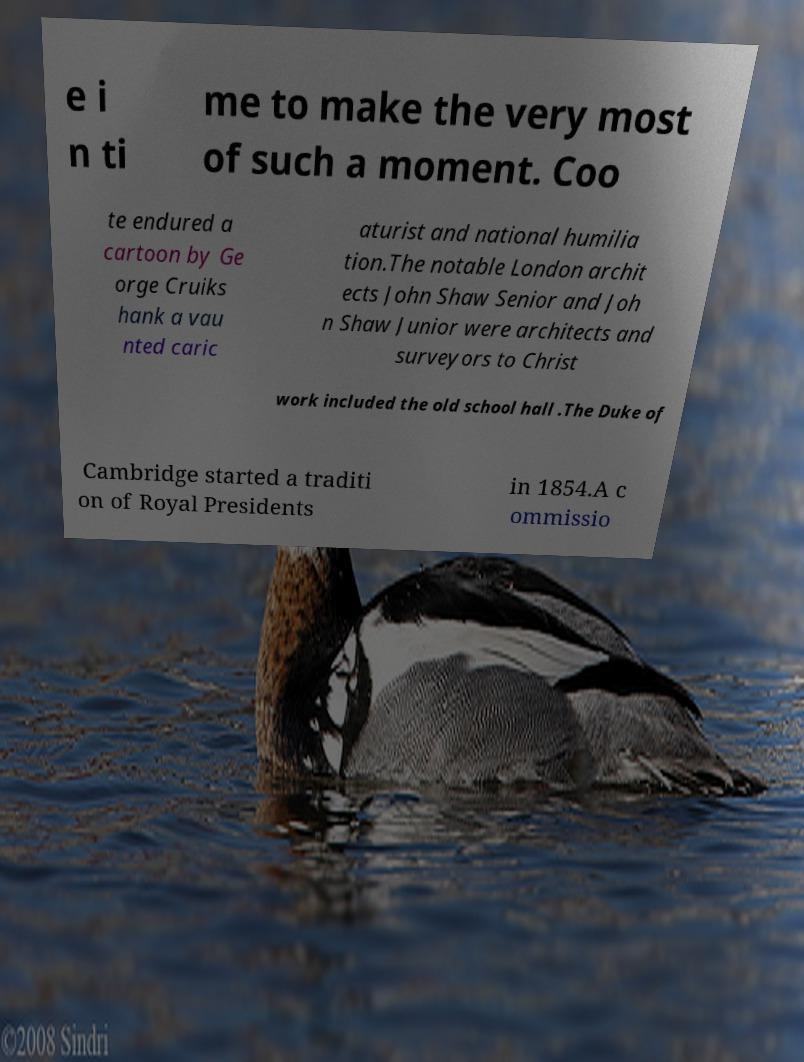There's text embedded in this image that I need extracted. Can you transcribe it verbatim? e i n ti me to make the very most of such a moment. Coo te endured a cartoon by Ge orge Cruiks hank a vau nted caric aturist and national humilia tion.The notable London archit ects John Shaw Senior and Joh n Shaw Junior were architects and surveyors to Christ work included the old school hall .The Duke of Cambridge started a traditi on of Royal Presidents in 1854.A c ommissio 